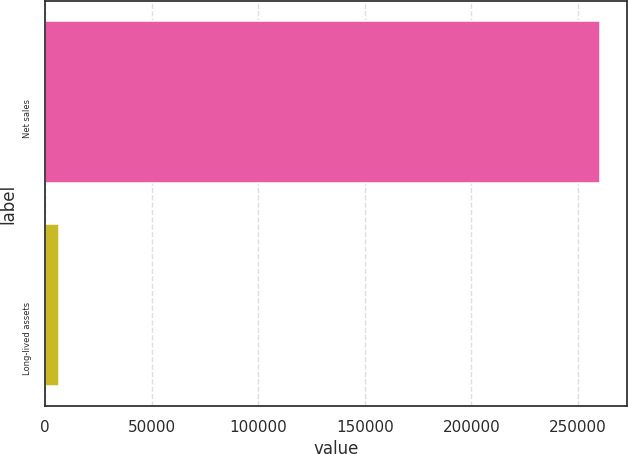<chart> <loc_0><loc_0><loc_500><loc_500><bar_chart><fcel>Net sales<fcel>Long-lived assets<nl><fcel>260125<fcel>6637<nl></chart> 